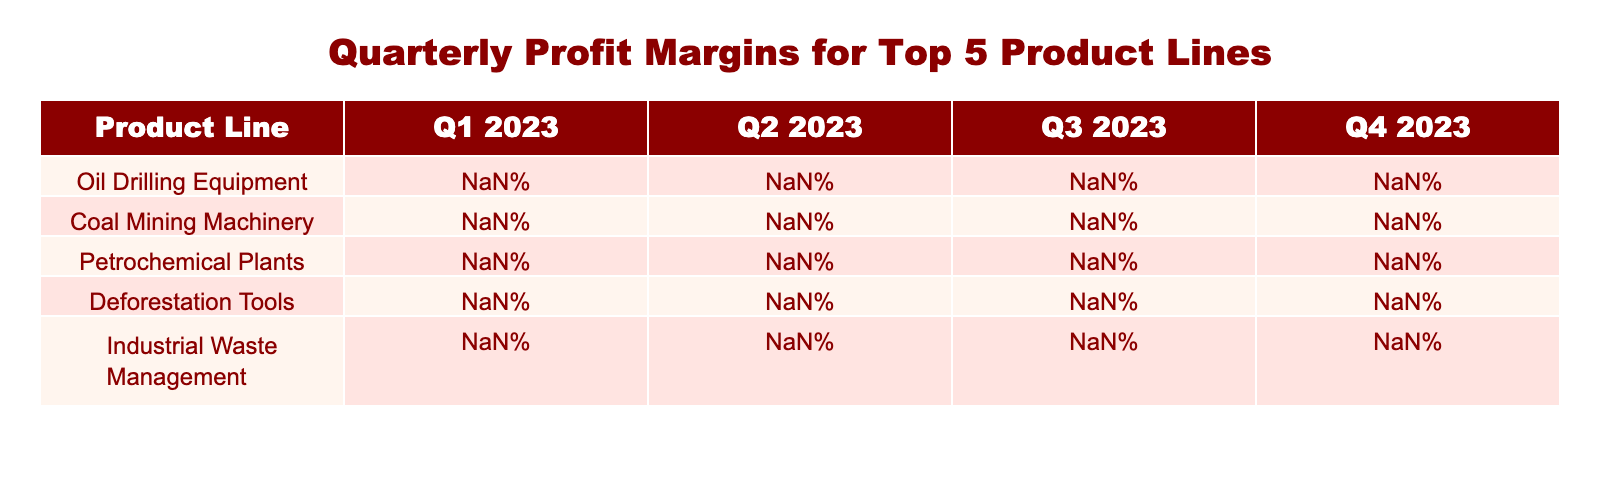What was the profit margin for Petrochemical Plants in Q3 2023? In the table, under the column for Q3 2023, we find the row for Petrochemical Plants. The value listed there is 29.0%.
Answer: 29.0% Which product line has the highest profit margin in Q4 2023? Looking at the Q4 2023 column, Oil Drilling Equipment has the highest value at 37.1%.
Answer: Oil Drilling Equipment What is the average profit margin for all product lines in Q1 2023? We sum the profit margins for all product lines in Q1 2023: 32.5 + 28.9 + 25.7 + 22.4 + 18.6 = 128.1%. There are 5 product lines, so the average is 128.1% / 5 = 25.62%.
Answer: 25.62% Is the profit margin for Industrial Waste Management greater than 20% in any quarter? In the given data, the profit margin for Industrial Waste Management is less than 20% in Q1 2023 (18.6%), but is greater than 20% in Q2 (20.2%), Q3 (21.9%), and Q4 (23.5%). Therefore, the statement is true.
Answer: Yes In which quarter did Deforestation Tools see the largest percentage increase in profit margin compared to the previous quarter? To find this, we look at Deforestation Tools: Q1 to Q2 (24.8 - 22.4 = 2.4), Q2 to Q3 (26.5 - 24.8 = 1.7), and Q3 to Q4 (28.3 - 26.5 = 1.8). The largest increase is from Q1 to Q2 with an increase of 2.4%.
Answer: Q1 to Q2 What is the difference in profit margin between Coal Mining Machinery in Q3 2023 and Q4 2023? The profit margin for Coal Mining Machinery in Q3 2023 is 31.5% and in Q4 2023 is 33.2%. The difference is 33.2% - 31.5% = 1.7%.
Answer: 1.7% Are there any product lines with a profit margin lower than 25% in Q1 2023? By checking the Q1 2023 column, we see that Petrochemical Plants (25.7%) and Deforestation Tools (22.4%) have values lower than 25%. Therefore, the answer is yes.
Answer: Yes Which product line had the smallest profit margin in Q4 2023? In the Q4 2023 column, we find the values: Oil Drilling Equipment (37.1%), Coal Mining Machinery (33.2%), Petrochemical Plants (30.6%), Deforestation Tools (28.3%), and Industrial Waste Management (23.5%). The smallest is Industrial Waste Management at 23.5%.
Answer: Industrial Waste Management 